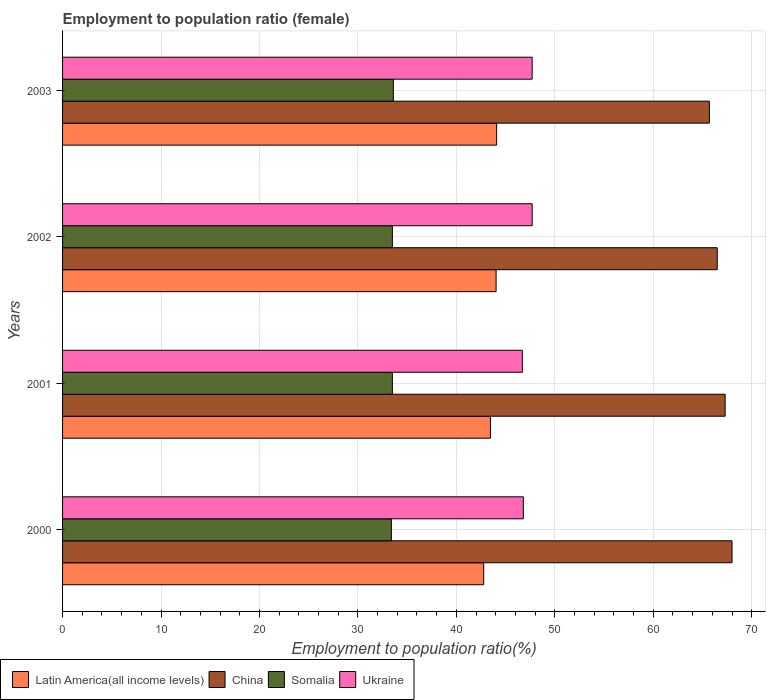How many groups of bars are there?
Offer a very short reply. 4. How many bars are there on the 1st tick from the top?
Your response must be concise. 4. How many bars are there on the 3rd tick from the bottom?
Offer a very short reply. 4. What is the employment to population ratio in Latin America(all income levels) in 2001?
Provide a succinct answer. 43.46. Across all years, what is the maximum employment to population ratio in Somalia?
Give a very brief answer. 33.6. Across all years, what is the minimum employment to population ratio in Somalia?
Keep it short and to the point. 33.4. In which year was the employment to population ratio in Somalia maximum?
Your response must be concise. 2003. In which year was the employment to population ratio in Somalia minimum?
Your answer should be very brief. 2000. What is the total employment to population ratio in Latin America(all income levels) in the graph?
Offer a very short reply. 174.36. What is the difference between the employment to population ratio in Latin America(all income levels) in 2001 and that in 2003?
Give a very brief answer. -0.63. What is the difference between the employment to population ratio in Latin America(all income levels) in 2003 and the employment to population ratio in Somalia in 2002?
Provide a succinct answer. 10.59. What is the average employment to population ratio in Latin America(all income levels) per year?
Your answer should be very brief. 43.59. In the year 2001, what is the difference between the employment to population ratio in Latin America(all income levels) and employment to population ratio in China?
Ensure brevity in your answer.  -23.84. What is the ratio of the employment to population ratio in Latin America(all income levels) in 2002 to that in 2003?
Give a very brief answer. 1. What is the difference between the highest and the second highest employment to population ratio in Somalia?
Offer a very short reply. 0.1. What is the difference between the highest and the lowest employment to population ratio in Ukraine?
Provide a succinct answer. 1. In how many years, is the employment to population ratio in Ukraine greater than the average employment to population ratio in Ukraine taken over all years?
Ensure brevity in your answer.  2. Is it the case that in every year, the sum of the employment to population ratio in Ukraine and employment to population ratio in Somalia is greater than the sum of employment to population ratio in China and employment to population ratio in Latin America(all income levels)?
Keep it short and to the point. No. What does the 4th bar from the top in 2001 represents?
Provide a short and direct response. Latin America(all income levels). What does the 3rd bar from the bottom in 2001 represents?
Offer a very short reply. Somalia. How many bars are there?
Offer a very short reply. 16. What is the difference between two consecutive major ticks on the X-axis?
Offer a very short reply. 10. Does the graph contain any zero values?
Your answer should be very brief. No. Where does the legend appear in the graph?
Keep it short and to the point. Bottom left. How many legend labels are there?
Keep it short and to the point. 4. How are the legend labels stacked?
Give a very brief answer. Horizontal. What is the title of the graph?
Offer a very short reply. Employment to population ratio (female). Does "Maldives" appear as one of the legend labels in the graph?
Make the answer very short. No. What is the Employment to population ratio(%) in Latin America(all income levels) in 2000?
Offer a terse response. 42.78. What is the Employment to population ratio(%) of China in 2000?
Give a very brief answer. 68. What is the Employment to population ratio(%) in Somalia in 2000?
Your answer should be very brief. 33.4. What is the Employment to population ratio(%) of Ukraine in 2000?
Offer a terse response. 46.8. What is the Employment to population ratio(%) in Latin America(all income levels) in 2001?
Make the answer very short. 43.46. What is the Employment to population ratio(%) of China in 2001?
Provide a succinct answer. 67.3. What is the Employment to population ratio(%) of Somalia in 2001?
Offer a very short reply. 33.5. What is the Employment to population ratio(%) of Ukraine in 2001?
Provide a short and direct response. 46.7. What is the Employment to population ratio(%) of Latin America(all income levels) in 2002?
Your answer should be very brief. 44.04. What is the Employment to population ratio(%) in China in 2002?
Your answer should be very brief. 66.5. What is the Employment to population ratio(%) in Somalia in 2002?
Your response must be concise. 33.5. What is the Employment to population ratio(%) of Ukraine in 2002?
Give a very brief answer. 47.7. What is the Employment to population ratio(%) of Latin America(all income levels) in 2003?
Your response must be concise. 44.09. What is the Employment to population ratio(%) in China in 2003?
Your answer should be compact. 65.7. What is the Employment to population ratio(%) of Somalia in 2003?
Ensure brevity in your answer.  33.6. What is the Employment to population ratio(%) of Ukraine in 2003?
Offer a very short reply. 47.7. Across all years, what is the maximum Employment to population ratio(%) of Latin America(all income levels)?
Provide a short and direct response. 44.09. Across all years, what is the maximum Employment to population ratio(%) of Somalia?
Keep it short and to the point. 33.6. Across all years, what is the maximum Employment to population ratio(%) in Ukraine?
Make the answer very short. 47.7. Across all years, what is the minimum Employment to population ratio(%) in Latin America(all income levels)?
Offer a terse response. 42.78. Across all years, what is the minimum Employment to population ratio(%) in China?
Offer a very short reply. 65.7. Across all years, what is the minimum Employment to population ratio(%) of Somalia?
Offer a very short reply. 33.4. Across all years, what is the minimum Employment to population ratio(%) of Ukraine?
Keep it short and to the point. 46.7. What is the total Employment to population ratio(%) in Latin America(all income levels) in the graph?
Ensure brevity in your answer.  174.36. What is the total Employment to population ratio(%) of China in the graph?
Your answer should be compact. 267.5. What is the total Employment to population ratio(%) of Somalia in the graph?
Give a very brief answer. 134. What is the total Employment to population ratio(%) of Ukraine in the graph?
Your response must be concise. 188.9. What is the difference between the Employment to population ratio(%) in Latin America(all income levels) in 2000 and that in 2001?
Give a very brief answer. -0.68. What is the difference between the Employment to population ratio(%) in China in 2000 and that in 2001?
Your answer should be compact. 0.7. What is the difference between the Employment to population ratio(%) of Ukraine in 2000 and that in 2001?
Your answer should be compact. 0.1. What is the difference between the Employment to population ratio(%) of Latin America(all income levels) in 2000 and that in 2002?
Offer a very short reply. -1.26. What is the difference between the Employment to population ratio(%) in China in 2000 and that in 2002?
Your answer should be compact. 1.5. What is the difference between the Employment to population ratio(%) of Latin America(all income levels) in 2000 and that in 2003?
Ensure brevity in your answer.  -1.31. What is the difference between the Employment to population ratio(%) in China in 2000 and that in 2003?
Offer a very short reply. 2.3. What is the difference between the Employment to population ratio(%) of Somalia in 2000 and that in 2003?
Offer a terse response. -0.2. What is the difference between the Employment to population ratio(%) of Latin America(all income levels) in 2001 and that in 2002?
Your answer should be compact. -0.58. What is the difference between the Employment to population ratio(%) in China in 2001 and that in 2002?
Ensure brevity in your answer.  0.8. What is the difference between the Employment to population ratio(%) of Ukraine in 2001 and that in 2002?
Provide a succinct answer. -1. What is the difference between the Employment to population ratio(%) in Latin America(all income levels) in 2001 and that in 2003?
Your response must be concise. -0.63. What is the difference between the Employment to population ratio(%) of Somalia in 2001 and that in 2003?
Ensure brevity in your answer.  -0.1. What is the difference between the Employment to population ratio(%) of Ukraine in 2001 and that in 2003?
Offer a very short reply. -1. What is the difference between the Employment to population ratio(%) in Latin America(all income levels) in 2002 and that in 2003?
Your answer should be very brief. -0.06. What is the difference between the Employment to population ratio(%) in Somalia in 2002 and that in 2003?
Offer a very short reply. -0.1. What is the difference between the Employment to population ratio(%) of Latin America(all income levels) in 2000 and the Employment to population ratio(%) of China in 2001?
Keep it short and to the point. -24.52. What is the difference between the Employment to population ratio(%) in Latin America(all income levels) in 2000 and the Employment to population ratio(%) in Somalia in 2001?
Provide a short and direct response. 9.28. What is the difference between the Employment to population ratio(%) in Latin America(all income levels) in 2000 and the Employment to population ratio(%) in Ukraine in 2001?
Your response must be concise. -3.92. What is the difference between the Employment to population ratio(%) in China in 2000 and the Employment to population ratio(%) in Somalia in 2001?
Make the answer very short. 34.5. What is the difference between the Employment to population ratio(%) of China in 2000 and the Employment to population ratio(%) of Ukraine in 2001?
Provide a short and direct response. 21.3. What is the difference between the Employment to population ratio(%) of Somalia in 2000 and the Employment to population ratio(%) of Ukraine in 2001?
Keep it short and to the point. -13.3. What is the difference between the Employment to population ratio(%) of Latin America(all income levels) in 2000 and the Employment to population ratio(%) of China in 2002?
Give a very brief answer. -23.72. What is the difference between the Employment to population ratio(%) in Latin America(all income levels) in 2000 and the Employment to population ratio(%) in Somalia in 2002?
Provide a short and direct response. 9.28. What is the difference between the Employment to population ratio(%) of Latin America(all income levels) in 2000 and the Employment to population ratio(%) of Ukraine in 2002?
Offer a very short reply. -4.92. What is the difference between the Employment to population ratio(%) in China in 2000 and the Employment to population ratio(%) in Somalia in 2002?
Your response must be concise. 34.5. What is the difference between the Employment to population ratio(%) in China in 2000 and the Employment to population ratio(%) in Ukraine in 2002?
Your answer should be compact. 20.3. What is the difference between the Employment to population ratio(%) of Somalia in 2000 and the Employment to population ratio(%) of Ukraine in 2002?
Provide a succinct answer. -14.3. What is the difference between the Employment to population ratio(%) of Latin America(all income levels) in 2000 and the Employment to population ratio(%) of China in 2003?
Your answer should be very brief. -22.92. What is the difference between the Employment to population ratio(%) in Latin America(all income levels) in 2000 and the Employment to population ratio(%) in Somalia in 2003?
Your response must be concise. 9.18. What is the difference between the Employment to population ratio(%) in Latin America(all income levels) in 2000 and the Employment to population ratio(%) in Ukraine in 2003?
Offer a terse response. -4.92. What is the difference between the Employment to population ratio(%) of China in 2000 and the Employment to population ratio(%) of Somalia in 2003?
Make the answer very short. 34.4. What is the difference between the Employment to population ratio(%) of China in 2000 and the Employment to population ratio(%) of Ukraine in 2003?
Make the answer very short. 20.3. What is the difference between the Employment to population ratio(%) of Somalia in 2000 and the Employment to population ratio(%) of Ukraine in 2003?
Your answer should be compact. -14.3. What is the difference between the Employment to population ratio(%) of Latin America(all income levels) in 2001 and the Employment to population ratio(%) of China in 2002?
Make the answer very short. -23.04. What is the difference between the Employment to population ratio(%) in Latin America(all income levels) in 2001 and the Employment to population ratio(%) in Somalia in 2002?
Offer a terse response. 9.96. What is the difference between the Employment to population ratio(%) in Latin America(all income levels) in 2001 and the Employment to population ratio(%) in Ukraine in 2002?
Offer a terse response. -4.24. What is the difference between the Employment to population ratio(%) of China in 2001 and the Employment to population ratio(%) of Somalia in 2002?
Your response must be concise. 33.8. What is the difference between the Employment to population ratio(%) of China in 2001 and the Employment to population ratio(%) of Ukraine in 2002?
Ensure brevity in your answer.  19.6. What is the difference between the Employment to population ratio(%) in Latin America(all income levels) in 2001 and the Employment to population ratio(%) in China in 2003?
Give a very brief answer. -22.24. What is the difference between the Employment to population ratio(%) of Latin America(all income levels) in 2001 and the Employment to population ratio(%) of Somalia in 2003?
Give a very brief answer. 9.86. What is the difference between the Employment to population ratio(%) in Latin America(all income levels) in 2001 and the Employment to population ratio(%) in Ukraine in 2003?
Provide a succinct answer. -4.24. What is the difference between the Employment to population ratio(%) in China in 2001 and the Employment to population ratio(%) in Somalia in 2003?
Provide a succinct answer. 33.7. What is the difference between the Employment to population ratio(%) of China in 2001 and the Employment to population ratio(%) of Ukraine in 2003?
Keep it short and to the point. 19.6. What is the difference between the Employment to population ratio(%) of Somalia in 2001 and the Employment to population ratio(%) of Ukraine in 2003?
Your answer should be very brief. -14.2. What is the difference between the Employment to population ratio(%) in Latin America(all income levels) in 2002 and the Employment to population ratio(%) in China in 2003?
Provide a succinct answer. -21.66. What is the difference between the Employment to population ratio(%) in Latin America(all income levels) in 2002 and the Employment to population ratio(%) in Somalia in 2003?
Your response must be concise. 10.44. What is the difference between the Employment to population ratio(%) in Latin America(all income levels) in 2002 and the Employment to population ratio(%) in Ukraine in 2003?
Offer a very short reply. -3.66. What is the difference between the Employment to population ratio(%) of China in 2002 and the Employment to population ratio(%) of Somalia in 2003?
Provide a succinct answer. 32.9. What is the average Employment to population ratio(%) in Latin America(all income levels) per year?
Offer a very short reply. 43.59. What is the average Employment to population ratio(%) of China per year?
Offer a terse response. 66.88. What is the average Employment to population ratio(%) of Somalia per year?
Offer a very short reply. 33.5. What is the average Employment to population ratio(%) of Ukraine per year?
Provide a succinct answer. 47.23. In the year 2000, what is the difference between the Employment to population ratio(%) of Latin America(all income levels) and Employment to population ratio(%) of China?
Keep it short and to the point. -25.22. In the year 2000, what is the difference between the Employment to population ratio(%) in Latin America(all income levels) and Employment to population ratio(%) in Somalia?
Provide a succinct answer. 9.38. In the year 2000, what is the difference between the Employment to population ratio(%) of Latin America(all income levels) and Employment to population ratio(%) of Ukraine?
Your answer should be compact. -4.02. In the year 2000, what is the difference between the Employment to population ratio(%) in China and Employment to population ratio(%) in Somalia?
Your response must be concise. 34.6. In the year 2000, what is the difference between the Employment to population ratio(%) of China and Employment to population ratio(%) of Ukraine?
Your answer should be compact. 21.2. In the year 2001, what is the difference between the Employment to population ratio(%) in Latin America(all income levels) and Employment to population ratio(%) in China?
Your answer should be compact. -23.84. In the year 2001, what is the difference between the Employment to population ratio(%) in Latin America(all income levels) and Employment to population ratio(%) in Somalia?
Your answer should be compact. 9.96. In the year 2001, what is the difference between the Employment to population ratio(%) in Latin America(all income levels) and Employment to population ratio(%) in Ukraine?
Offer a very short reply. -3.24. In the year 2001, what is the difference between the Employment to population ratio(%) of China and Employment to population ratio(%) of Somalia?
Provide a short and direct response. 33.8. In the year 2001, what is the difference between the Employment to population ratio(%) in China and Employment to population ratio(%) in Ukraine?
Your answer should be very brief. 20.6. In the year 2001, what is the difference between the Employment to population ratio(%) in Somalia and Employment to population ratio(%) in Ukraine?
Ensure brevity in your answer.  -13.2. In the year 2002, what is the difference between the Employment to population ratio(%) in Latin America(all income levels) and Employment to population ratio(%) in China?
Give a very brief answer. -22.46. In the year 2002, what is the difference between the Employment to population ratio(%) in Latin America(all income levels) and Employment to population ratio(%) in Somalia?
Offer a very short reply. 10.54. In the year 2002, what is the difference between the Employment to population ratio(%) of Latin America(all income levels) and Employment to population ratio(%) of Ukraine?
Your response must be concise. -3.66. In the year 2002, what is the difference between the Employment to population ratio(%) of China and Employment to population ratio(%) of Somalia?
Ensure brevity in your answer.  33. In the year 2002, what is the difference between the Employment to population ratio(%) of Somalia and Employment to population ratio(%) of Ukraine?
Keep it short and to the point. -14.2. In the year 2003, what is the difference between the Employment to population ratio(%) of Latin America(all income levels) and Employment to population ratio(%) of China?
Your response must be concise. -21.61. In the year 2003, what is the difference between the Employment to population ratio(%) of Latin America(all income levels) and Employment to population ratio(%) of Somalia?
Provide a short and direct response. 10.49. In the year 2003, what is the difference between the Employment to population ratio(%) in Latin America(all income levels) and Employment to population ratio(%) in Ukraine?
Ensure brevity in your answer.  -3.61. In the year 2003, what is the difference between the Employment to population ratio(%) of China and Employment to population ratio(%) of Somalia?
Give a very brief answer. 32.1. In the year 2003, what is the difference between the Employment to population ratio(%) in China and Employment to population ratio(%) in Ukraine?
Your answer should be very brief. 18. In the year 2003, what is the difference between the Employment to population ratio(%) in Somalia and Employment to population ratio(%) in Ukraine?
Your answer should be compact. -14.1. What is the ratio of the Employment to population ratio(%) of Latin America(all income levels) in 2000 to that in 2001?
Your answer should be very brief. 0.98. What is the ratio of the Employment to population ratio(%) of China in 2000 to that in 2001?
Your answer should be compact. 1.01. What is the ratio of the Employment to population ratio(%) in Latin America(all income levels) in 2000 to that in 2002?
Make the answer very short. 0.97. What is the ratio of the Employment to population ratio(%) of China in 2000 to that in 2002?
Offer a terse response. 1.02. What is the ratio of the Employment to population ratio(%) in Somalia in 2000 to that in 2002?
Ensure brevity in your answer.  1. What is the ratio of the Employment to population ratio(%) in Ukraine in 2000 to that in 2002?
Give a very brief answer. 0.98. What is the ratio of the Employment to population ratio(%) in Latin America(all income levels) in 2000 to that in 2003?
Offer a terse response. 0.97. What is the ratio of the Employment to population ratio(%) of China in 2000 to that in 2003?
Provide a succinct answer. 1.03. What is the ratio of the Employment to population ratio(%) of Ukraine in 2000 to that in 2003?
Offer a terse response. 0.98. What is the ratio of the Employment to population ratio(%) in Latin America(all income levels) in 2001 to that in 2002?
Ensure brevity in your answer.  0.99. What is the ratio of the Employment to population ratio(%) in Ukraine in 2001 to that in 2002?
Your response must be concise. 0.98. What is the ratio of the Employment to population ratio(%) of Latin America(all income levels) in 2001 to that in 2003?
Give a very brief answer. 0.99. What is the ratio of the Employment to population ratio(%) of China in 2001 to that in 2003?
Your answer should be very brief. 1.02. What is the ratio of the Employment to population ratio(%) of Latin America(all income levels) in 2002 to that in 2003?
Offer a terse response. 1. What is the ratio of the Employment to population ratio(%) of China in 2002 to that in 2003?
Give a very brief answer. 1.01. What is the ratio of the Employment to population ratio(%) in Somalia in 2002 to that in 2003?
Offer a terse response. 1. What is the ratio of the Employment to population ratio(%) of Ukraine in 2002 to that in 2003?
Your answer should be compact. 1. What is the difference between the highest and the second highest Employment to population ratio(%) of Latin America(all income levels)?
Offer a terse response. 0.06. What is the difference between the highest and the second highest Employment to population ratio(%) in China?
Provide a short and direct response. 0.7. What is the difference between the highest and the second highest Employment to population ratio(%) in Ukraine?
Your response must be concise. 0. What is the difference between the highest and the lowest Employment to population ratio(%) of Latin America(all income levels)?
Your answer should be compact. 1.31. What is the difference between the highest and the lowest Employment to population ratio(%) of Somalia?
Your response must be concise. 0.2. What is the difference between the highest and the lowest Employment to population ratio(%) of Ukraine?
Your response must be concise. 1. 